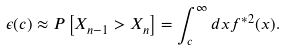Convert formula to latex. <formula><loc_0><loc_0><loc_500><loc_500>\epsilon ( c ) \approx P \left [ X _ { n - 1 } > X _ { n } \right ] = \int _ { c } ^ { \infty } d x f ^ { * 2 } ( x ) .</formula> 